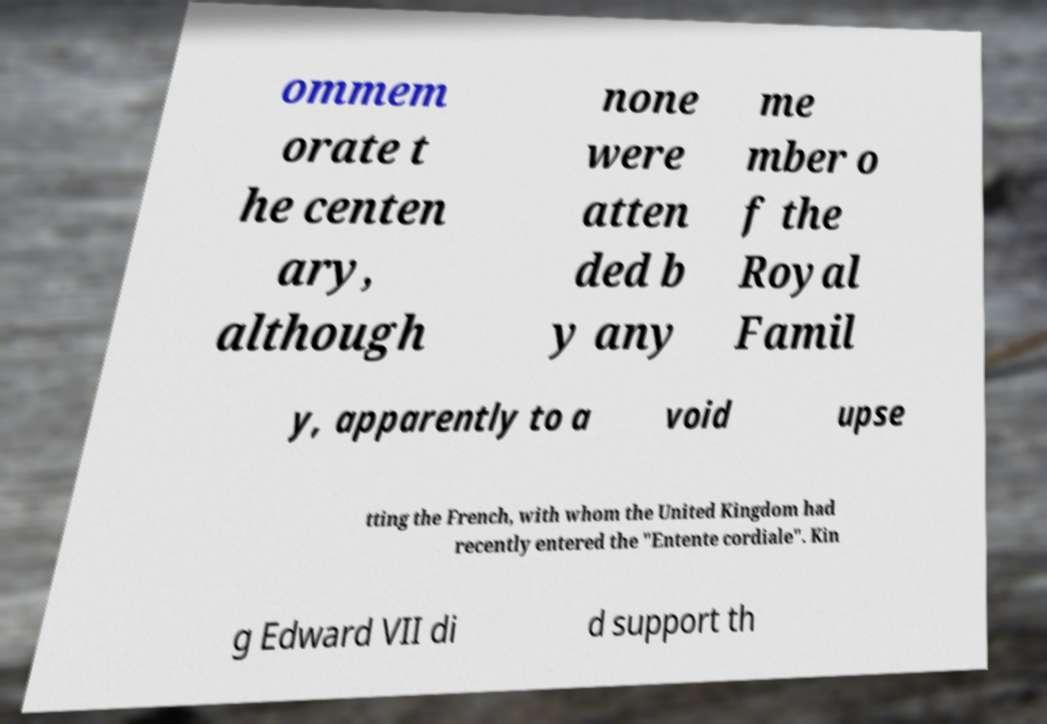Could you assist in decoding the text presented in this image and type it out clearly? ommem orate t he centen ary, although none were atten ded b y any me mber o f the Royal Famil y, apparently to a void upse tting the French, with whom the United Kingdom had recently entered the "Entente cordiale". Kin g Edward VII di d support th 